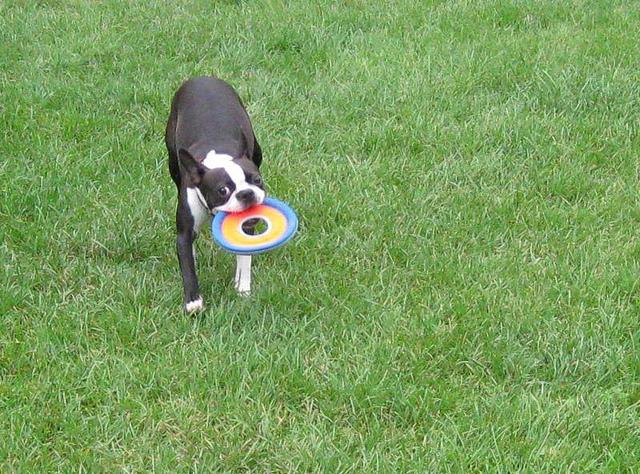What is around the dog's neck?
Short answer required. Collar. What color is the grass?
Give a very brief answer. Green. Did the dog just catch a frisbee?
Keep it brief. Yes. What image is on the frisbee?
Give a very brief answer. No image. What is the dog holding?
Short answer required. Frisbee. 